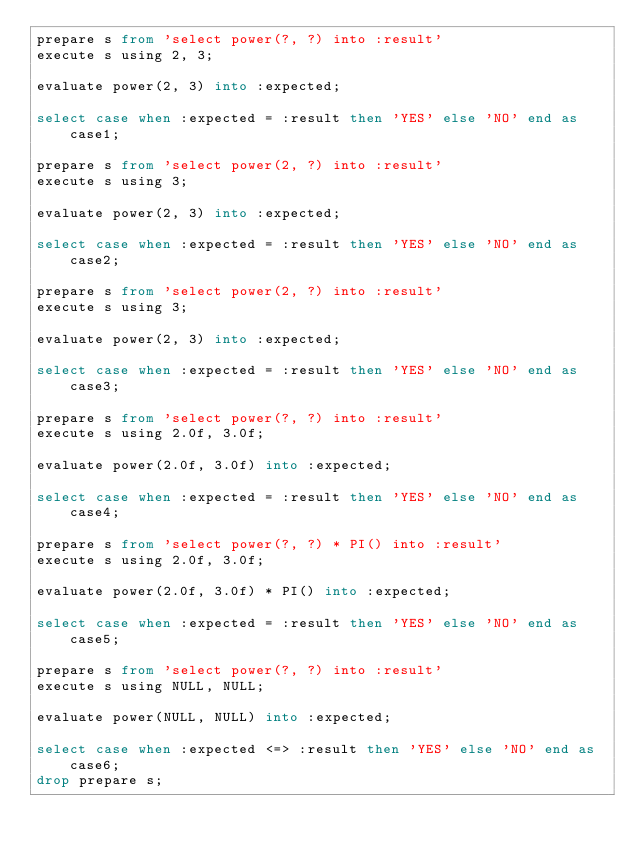<code> <loc_0><loc_0><loc_500><loc_500><_SQL_>prepare s from 'select power(?, ?) into :result'
execute s using 2, 3;

evaluate power(2, 3) into :expected; 

select case when :expected = :result then 'YES' else 'NO' end as case1;

prepare s from 'select power(2, ?) into :result'
execute s using 3;

evaluate power(2, 3) into :expected; 

select case when :expected = :result then 'YES' else 'NO' end as case2;

prepare s from 'select power(2, ?) into :result'
execute s using 3;

evaluate power(2, 3) into :expected; 

select case when :expected = :result then 'YES' else 'NO' end as case3;

prepare s from 'select power(?, ?) into :result'
execute s using 2.0f, 3.0f;

evaluate power(2.0f, 3.0f) into :expected; 

select case when :expected = :result then 'YES' else 'NO' end as case4;

prepare s from 'select power(?, ?) * PI() into :result'
execute s using 2.0f, 3.0f;

evaluate power(2.0f, 3.0f) * PI() into :expected; 

select case when :expected = :result then 'YES' else 'NO' end as case5;

prepare s from 'select power(?, ?) into :result'
execute s using NULL, NULL;

evaluate power(NULL, NULL) into :expected; 

select case when :expected <=> :result then 'YES' else 'NO' end as case6;
drop prepare s;
</code> 